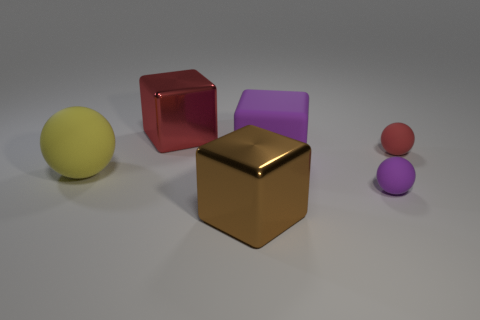Do the shiny object that is behind the small purple sphere and the tiny purple object have the same shape?
Make the answer very short. No. Is there anything else that is the same material as the brown cube?
Ensure brevity in your answer.  Yes. How many objects are red objects or large shiny cubes that are left of the brown object?
Provide a short and direct response. 2. What size is the matte object that is on the left side of the tiny purple matte sphere and to the right of the big sphere?
Keep it short and to the point. Large. Is the number of tiny purple matte spheres that are to the right of the tiny red matte object greater than the number of big brown shiny objects behind the purple matte cube?
Provide a succinct answer. No. Do the yellow object and the red rubber thing to the right of the red metallic block have the same shape?
Make the answer very short. Yes. What is the color of the thing that is both to the left of the small purple matte sphere and behind the big purple rubber block?
Offer a terse response. Red. The big ball is what color?
Make the answer very short. Yellow. Do the large yellow ball and the sphere that is in front of the yellow matte thing have the same material?
Keep it short and to the point. Yes. What is the shape of the large red thing that is the same material as the brown cube?
Your response must be concise. Cube. 